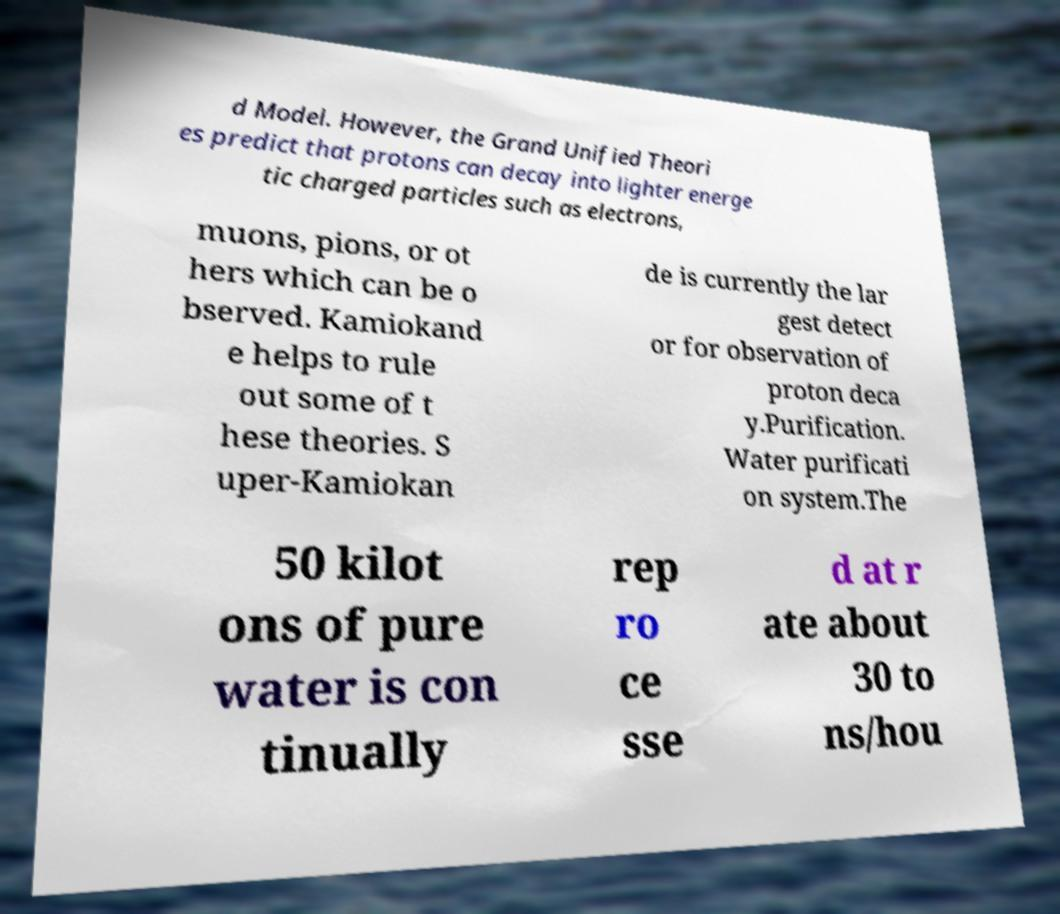Could you extract and type out the text from this image? d Model. However, the Grand Unified Theori es predict that protons can decay into lighter energe tic charged particles such as electrons, muons, pions, or ot hers which can be o bserved. Kamiokand e helps to rule out some of t hese theories. S uper-Kamiokan de is currently the lar gest detect or for observation of proton deca y.Purification. Water purificati on system.The 50 kilot ons of pure water is con tinually rep ro ce sse d at r ate about 30 to ns/hou 